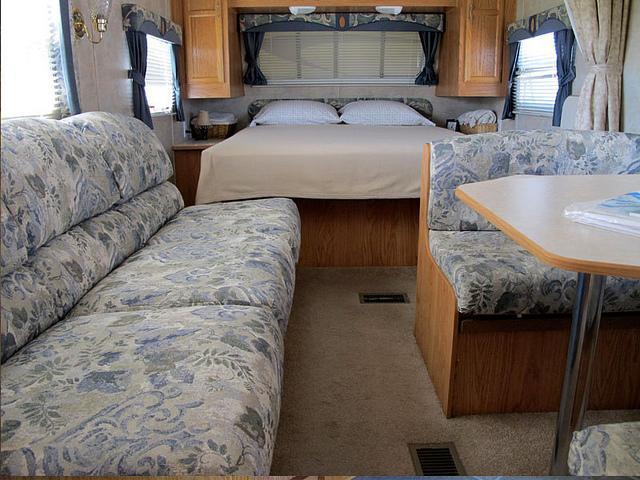How many couches are in the photo?
Give a very brief answer. 2. How many people are on the deck level of the boat?
Give a very brief answer. 0. 